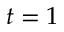<formula> <loc_0><loc_0><loc_500><loc_500>t = 1</formula> 